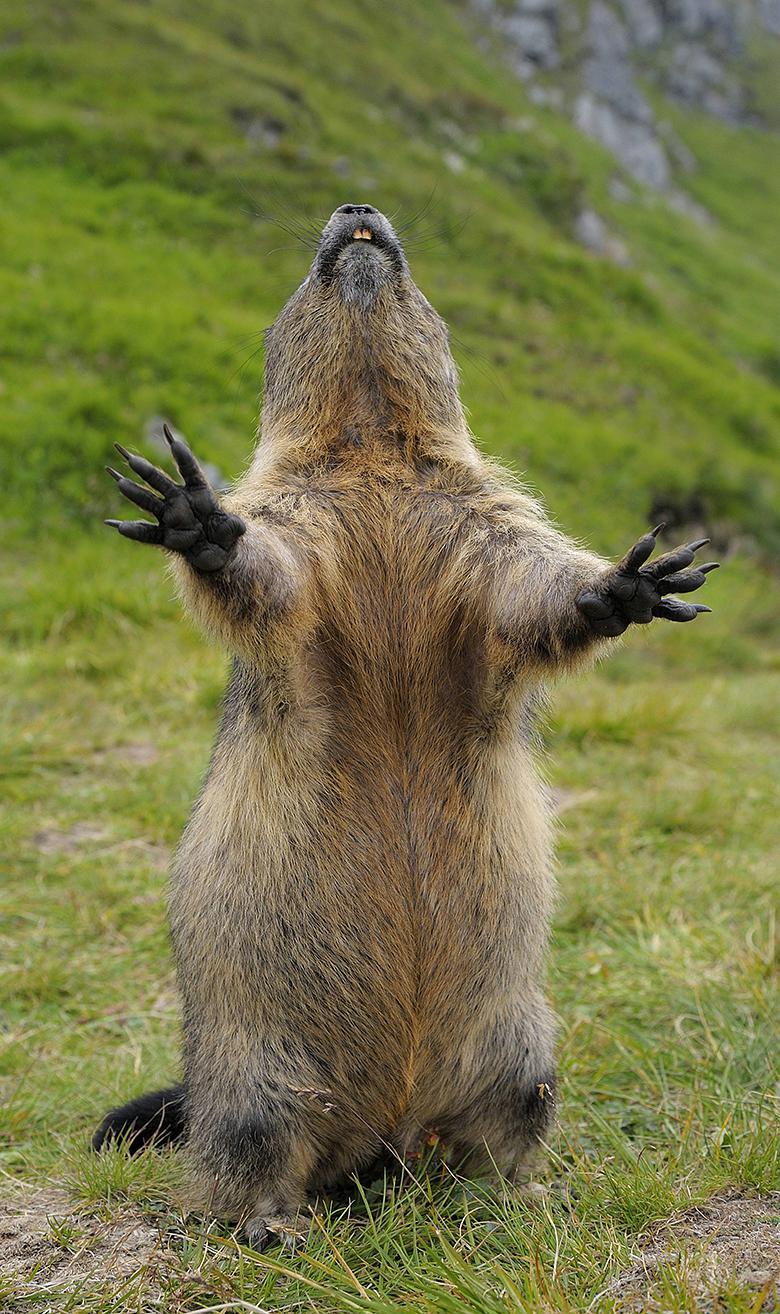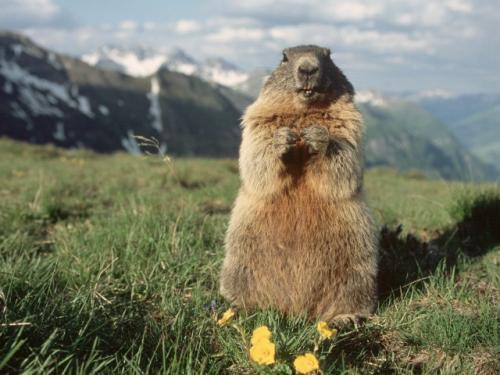The first image is the image on the left, the second image is the image on the right. For the images shown, is this caption "There is at least one prairie dog standing on its hind legs." true? Answer yes or no. Yes. 